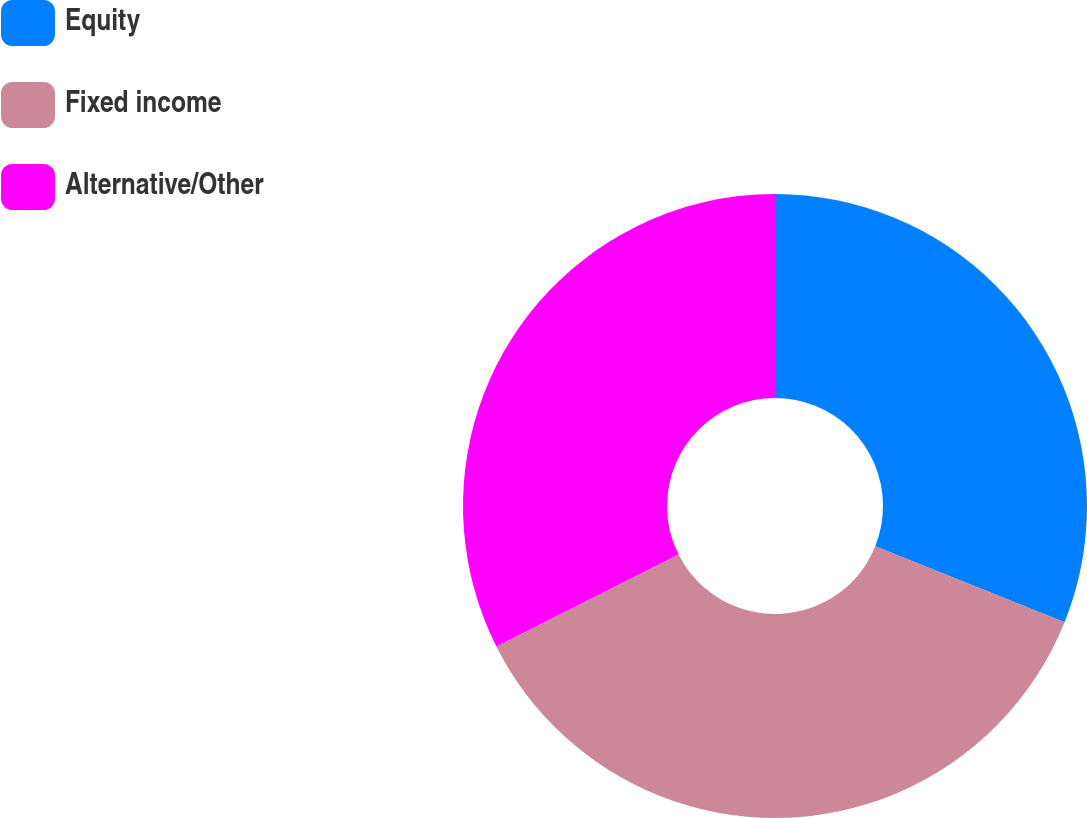Convert chart to OTSL. <chart><loc_0><loc_0><loc_500><loc_500><pie_chart><fcel>Equity<fcel>Fixed income<fcel>Alternative/Other<nl><fcel>31.08%<fcel>36.49%<fcel>32.43%<nl></chart> 